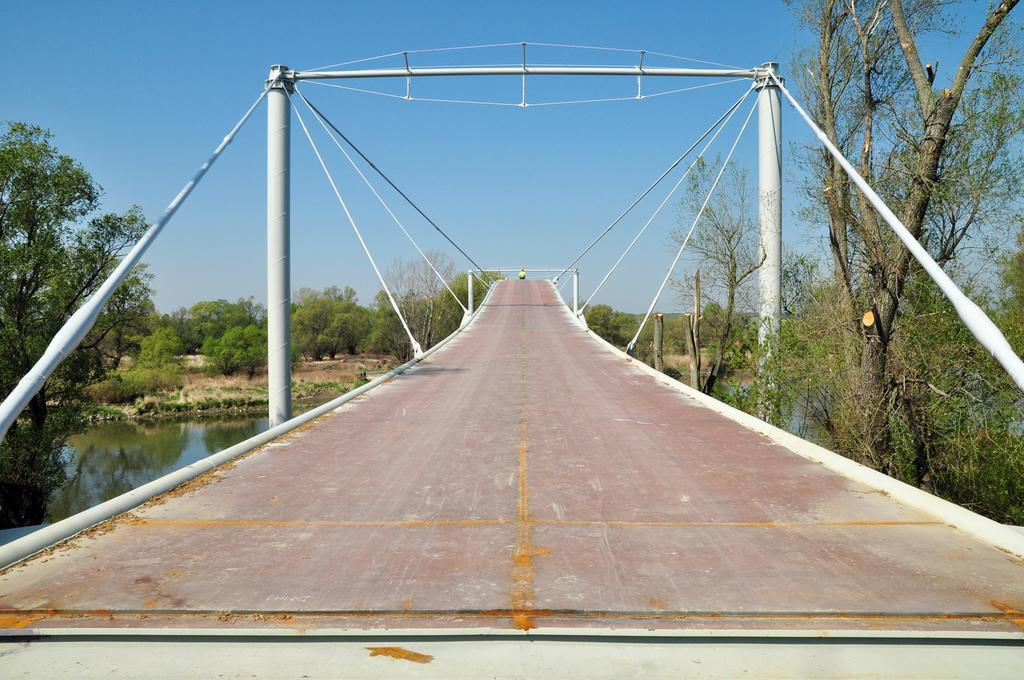Who or what is present in the image? There is a person in the image. Where is the person located? The person is on a bridge. What else can be seen in the image besides the person? There are poles, a water body, a group of trees, plants, and the sky visible in the image. What type of chess piece is located on the bridge in the image? There is no chess piece present in the image; it features a person on a bridge with other elements mentioned in the facts. 